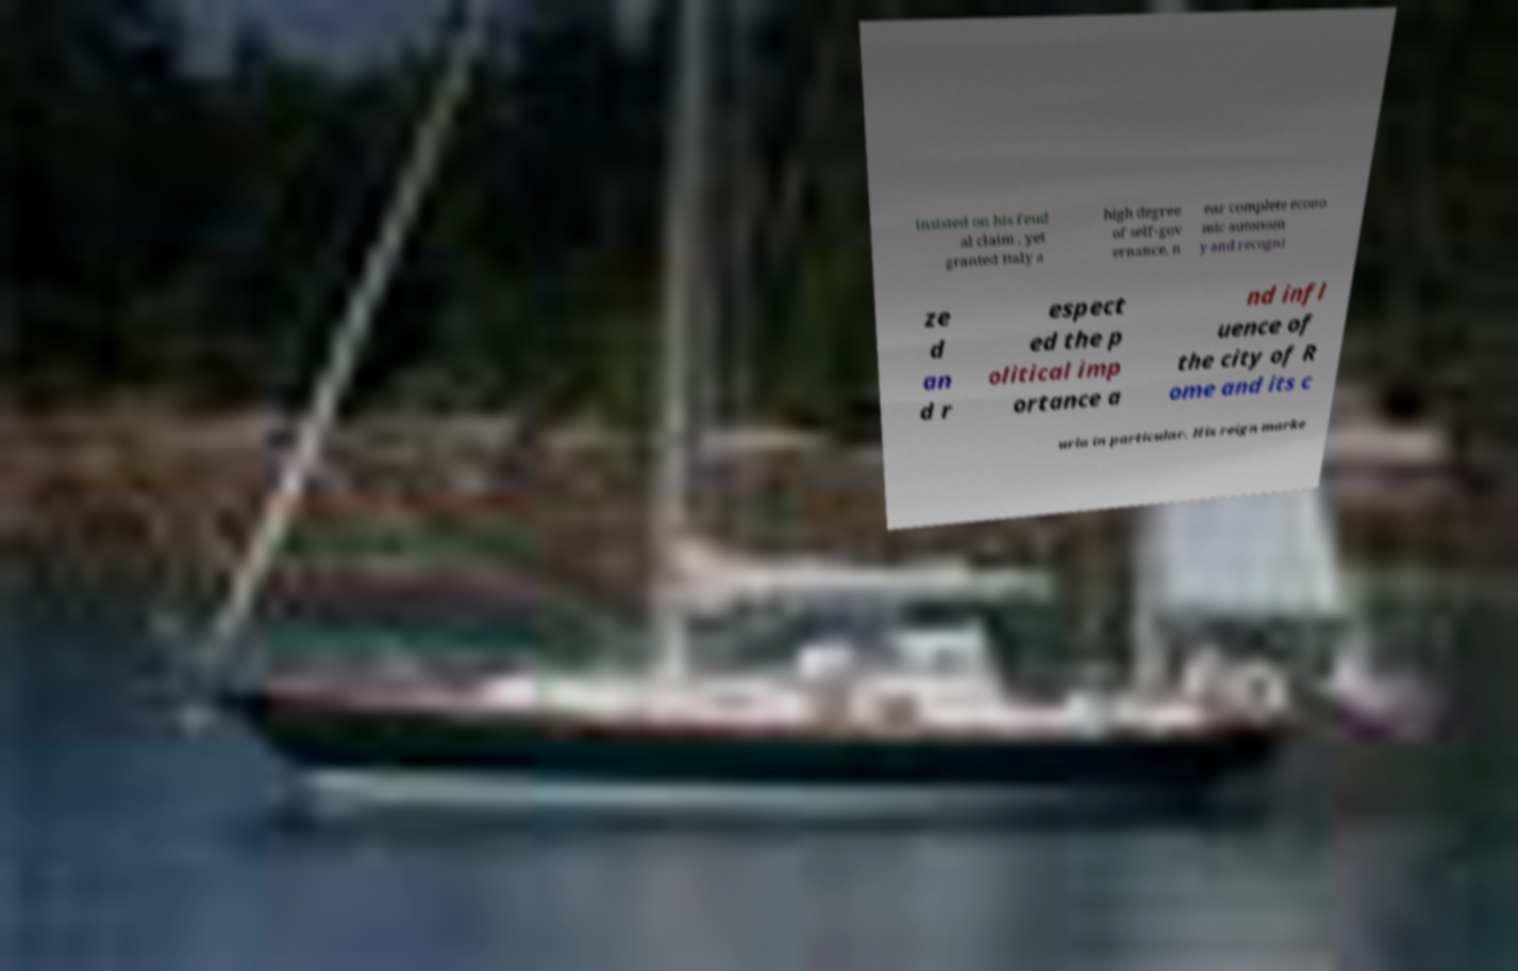I need the written content from this picture converted into text. Can you do that? insisted on his feud al claim , yet granted Italy a high degree of self-gov ernance, n ear complete econo mic autonom y and recogni ze d an d r espect ed the p olitical imp ortance a nd infl uence of the city of R ome and its c uria in particular. His reign marke 